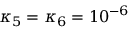Convert formula to latex. <formula><loc_0><loc_0><loc_500><loc_500>\kappa _ { 5 } = \kappa _ { 6 } = 1 0 ^ { - 6 }</formula> 